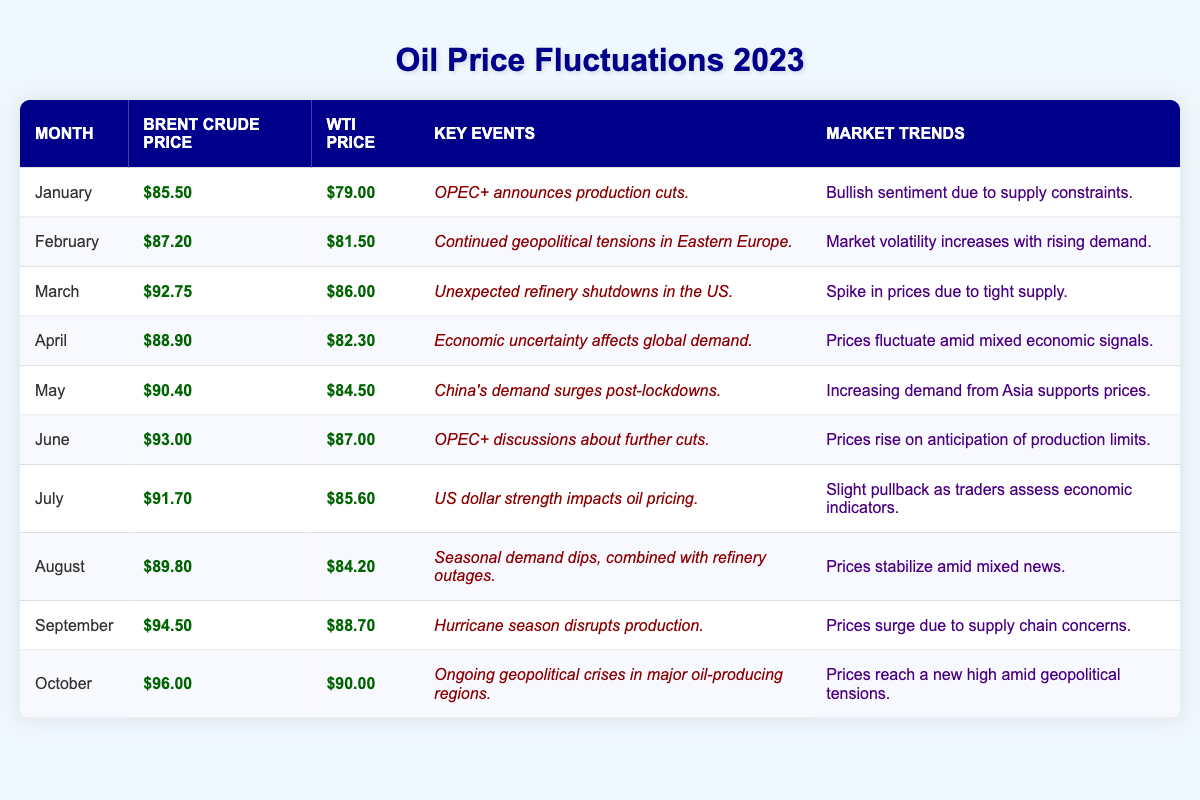What was the Brent Crude Price in March? The table shows that the Brent Crude Price in March is listed as $92.75.
Answer: $92.75 Which month had the highest WTI Price? Looking through the WTI Prices in the table, October has the highest value at $90.00.
Answer: $90.00 What was the average Brent Crude Price from January to April? The Brent Crude Prices from January to April are $85.50, $87.20, $92.75, and $88.90. The sum is $354.35, and there are 4 months, so the average is $354.35 / 4 = $88.59.
Answer: $88.59 Was there a price increase from September to October for WTI? The WTI Price in September is $88.70, and in October it is $90.00. Since $90.00 is greater than $88.70, there was an increase.
Answer: Yes How much did the Brent Crude Price increase from January to October? The Brent Crude Price was $85.50 in January and $96.00 in October. The increase is $96.00 - $85.50 = $10.50.
Answer: $10.50 What are the market trends for May? The table indicates that the market trend in May is "Increasing demand from Asia supports prices."
Answer: Increasing demand from Asia supports prices Which months experienced geopolitical events affecting oil prices? The months with geopolitical events are February (Eastern Europe), September (Hurricane season), and October (geopolitical crises).
Answer: February, September, October What was the WTI Price in July compared to the price in February? The WTI Price in February is $81.50, and in July, it is $85.60. The comparison shows price growth as July's price is higher.
Answer: July's price is higher In which month did OPEC+ discuss further production cuts, and what was the effect on prices? OPEC+ discussions about further cuts occurred in June, leading to a price rise where Brent Crude reached $93.00 and WTI reached $87.00.
Answer: June, prices rose 